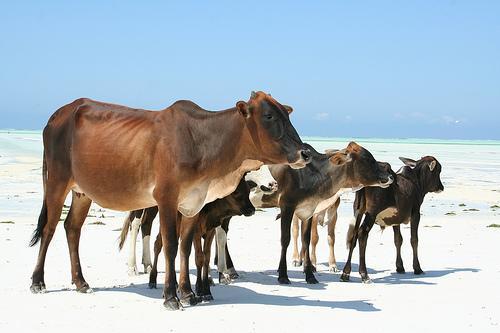How many large humps are on the largest cow?
Give a very brief answer. 1. How many animals are standing?
Give a very brief answer. 4. How many animals are in the photo?
Give a very brief answer. 4. 